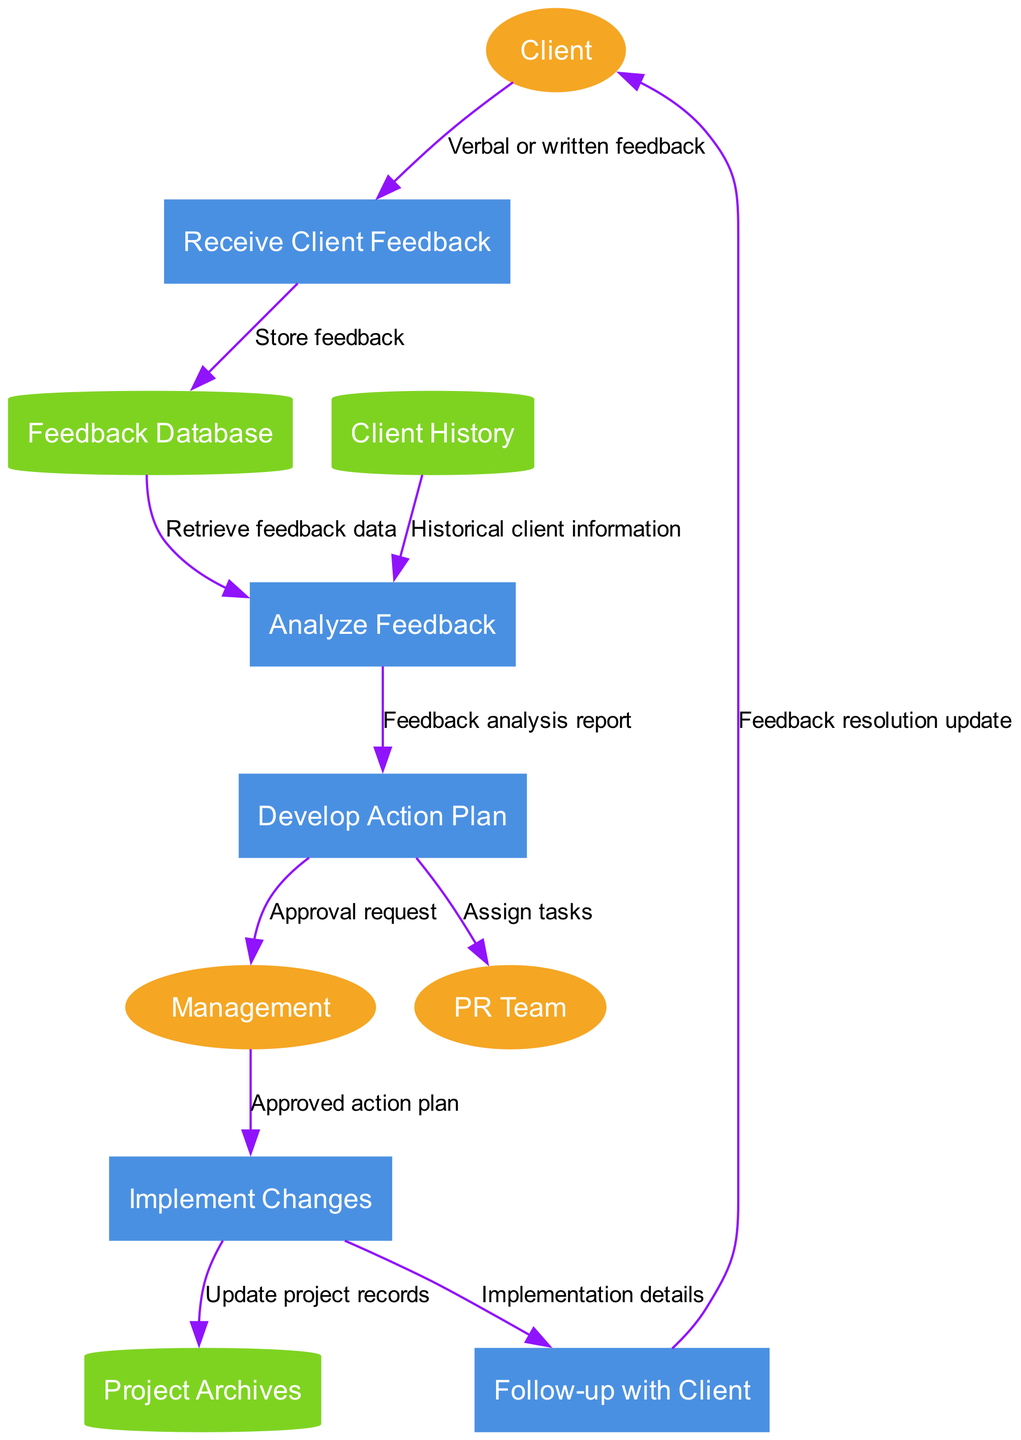What are the external entities in the diagram? The external entities, as indicated in the diagram, include sources that interact with the processes. These are labeled as "Client," "PR Team," and "Management."
Answer: Client, PR Team, Management How many processes are in the diagram? By counting the labeled processes within the diagram, we find a total of five distinct processes present. The processes are: "Receive Client Feedback," "Analyze Feedback," "Develop Action Plan," "Implement Changes," and "Follow-up with Client."
Answer: 5 What is the first process in the flow? The first process is identified as "Receive Client Feedback," which is the starting point for the client feedback management process where client feedback is initially collected.
Answer: Receive Client Feedback What type of data store is "Feedback Database"? The "Feedback Database" is represented as a cylinder in the diagram, which is a standard shape for data stores in data flow diagrams. This indicates that it is a storage repository for feedback data.
Answer: Cylinder Which process directly follows "Analyze Feedback"? The immediate successor to the "Analyze Feedback" process is "Develop Action Plan." This flow denotes that after analyzing the feedback, an action plan is formulated based on that analysis.
Answer: Develop Action Plan What is the flow from "Management" to "Implement Changes"? The flow from "Management" to "Implement Changes" is labeled as "Approved action plan," indicating that this is the necessary approval that allows for the implementation of changes.
Answer: Approved action plan Which external entity receives the "Feedback resolution update"? The "Feedback resolution update" is sent back to the "Client," representing the conclusion of the feedback management process where clients are informed about how their feedback has been addressed.
Answer: Client How many data stores are present in the diagram? The diagram includes three data stores: "Feedback Database," "Client History," and "Project Archives," which are all critical for storing relevant data.
Answer: 3 